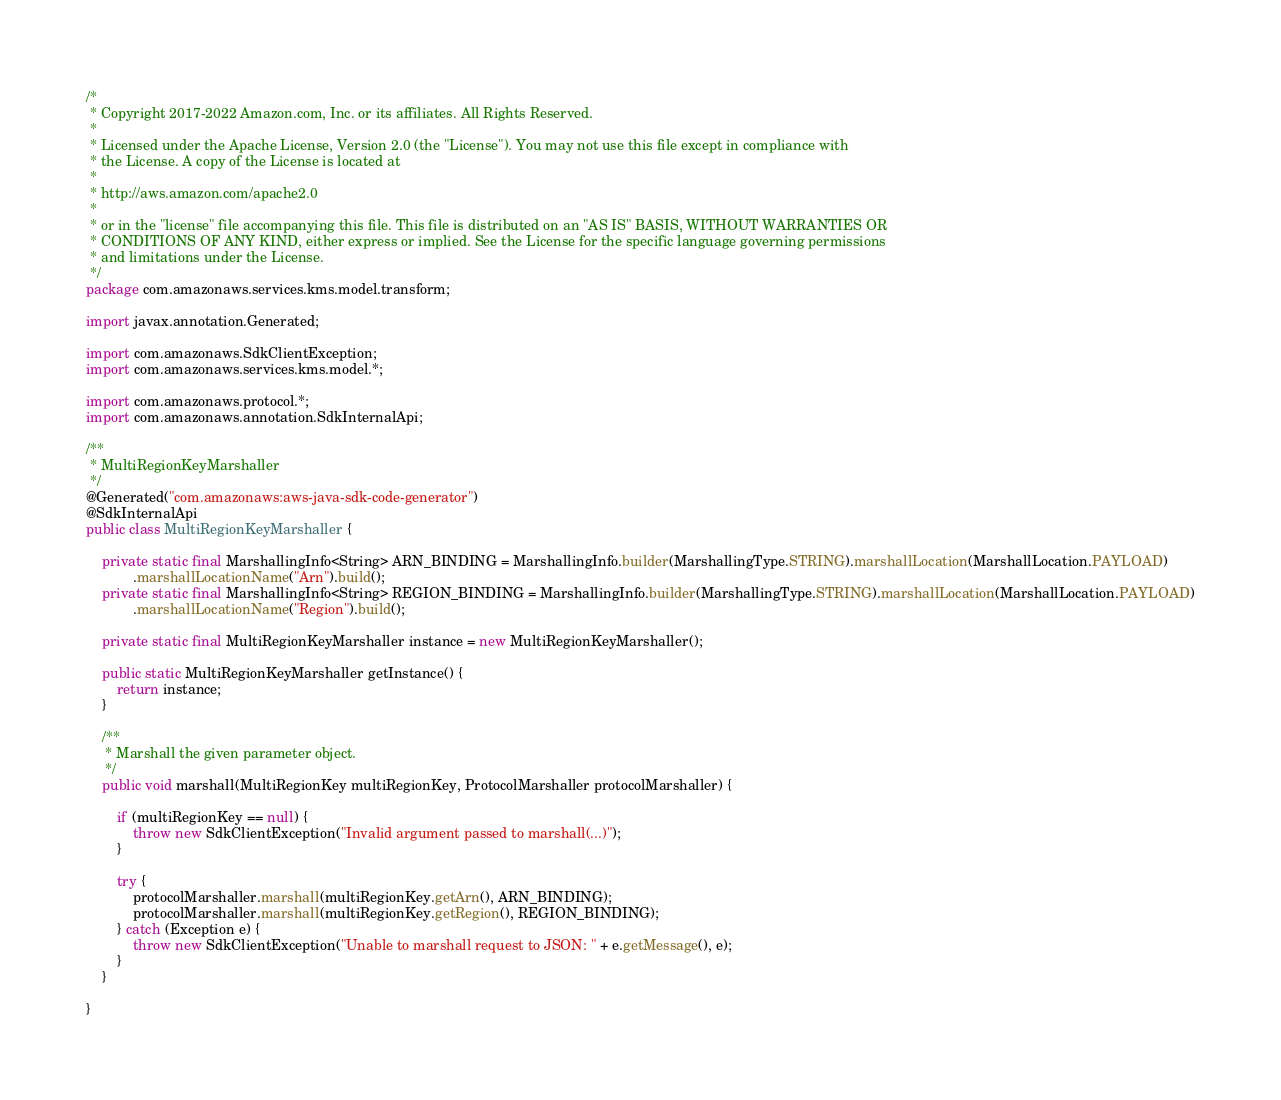<code> <loc_0><loc_0><loc_500><loc_500><_Java_>/*
 * Copyright 2017-2022 Amazon.com, Inc. or its affiliates. All Rights Reserved.
 * 
 * Licensed under the Apache License, Version 2.0 (the "License"). You may not use this file except in compliance with
 * the License. A copy of the License is located at
 * 
 * http://aws.amazon.com/apache2.0
 * 
 * or in the "license" file accompanying this file. This file is distributed on an "AS IS" BASIS, WITHOUT WARRANTIES OR
 * CONDITIONS OF ANY KIND, either express or implied. See the License for the specific language governing permissions
 * and limitations under the License.
 */
package com.amazonaws.services.kms.model.transform;

import javax.annotation.Generated;

import com.amazonaws.SdkClientException;
import com.amazonaws.services.kms.model.*;

import com.amazonaws.protocol.*;
import com.amazonaws.annotation.SdkInternalApi;

/**
 * MultiRegionKeyMarshaller
 */
@Generated("com.amazonaws:aws-java-sdk-code-generator")
@SdkInternalApi
public class MultiRegionKeyMarshaller {

    private static final MarshallingInfo<String> ARN_BINDING = MarshallingInfo.builder(MarshallingType.STRING).marshallLocation(MarshallLocation.PAYLOAD)
            .marshallLocationName("Arn").build();
    private static final MarshallingInfo<String> REGION_BINDING = MarshallingInfo.builder(MarshallingType.STRING).marshallLocation(MarshallLocation.PAYLOAD)
            .marshallLocationName("Region").build();

    private static final MultiRegionKeyMarshaller instance = new MultiRegionKeyMarshaller();

    public static MultiRegionKeyMarshaller getInstance() {
        return instance;
    }

    /**
     * Marshall the given parameter object.
     */
    public void marshall(MultiRegionKey multiRegionKey, ProtocolMarshaller protocolMarshaller) {

        if (multiRegionKey == null) {
            throw new SdkClientException("Invalid argument passed to marshall(...)");
        }

        try {
            protocolMarshaller.marshall(multiRegionKey.getArn(), ARN_BINDING);
            protocolMarshaller.marshall(multiRegionKey.getRegion(), REGION_BINDING);
        } catch (Exception e) {
            throw new SdkClientException("Unable to marshall request to JSON: " + e.getMessage(), e);
        }
    }

}
</code> 